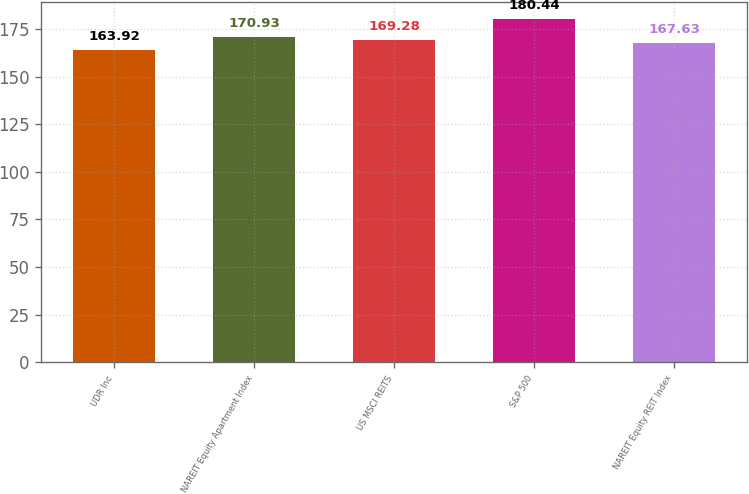Convert chart. <chart><loc_0><loc_0><loc_500><loc_500><bar_chart><fcel>UDR Inc<fcel>NAREIT Equity Apartment Index<fcel>US MSCI REITS<fcel>S&P 500<fcel>NAREIT Equity REIT Index<nl><fcel>163.92<fcel>170.93<fcel>169.28<fcel>180.44<fcel>167.63<nl></chart> 